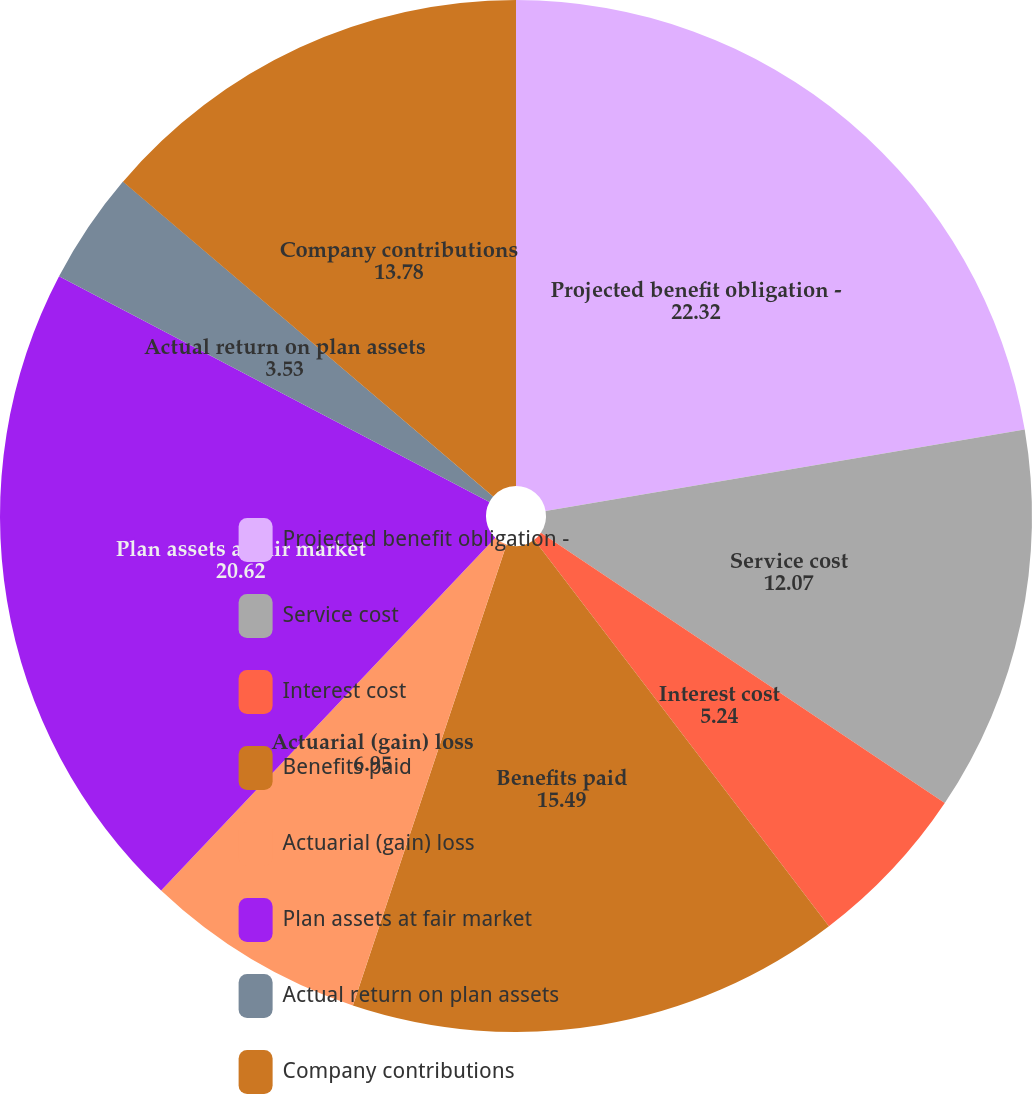Convert chart to OTSL. <chart><loc_0><loc_0><loc_500><loc_500><pie_chart><fcel>Projected benefit obligation -<fcel>Service cost<fcel>Interest cost<fcel>Benefits paid<fcel>Actuarial (gain) loss<fcel>Plan assets at fair market<fcel>Actual return on plan assets<fcel>Company contributions<nl><fcel>22.32%<fcel>12.07%<fcel>5.24%<fcel>15.49%<fcel>6.95%<fcel>20.62%<fcel>3.53%<fcel>13.78%<nl></chart> 